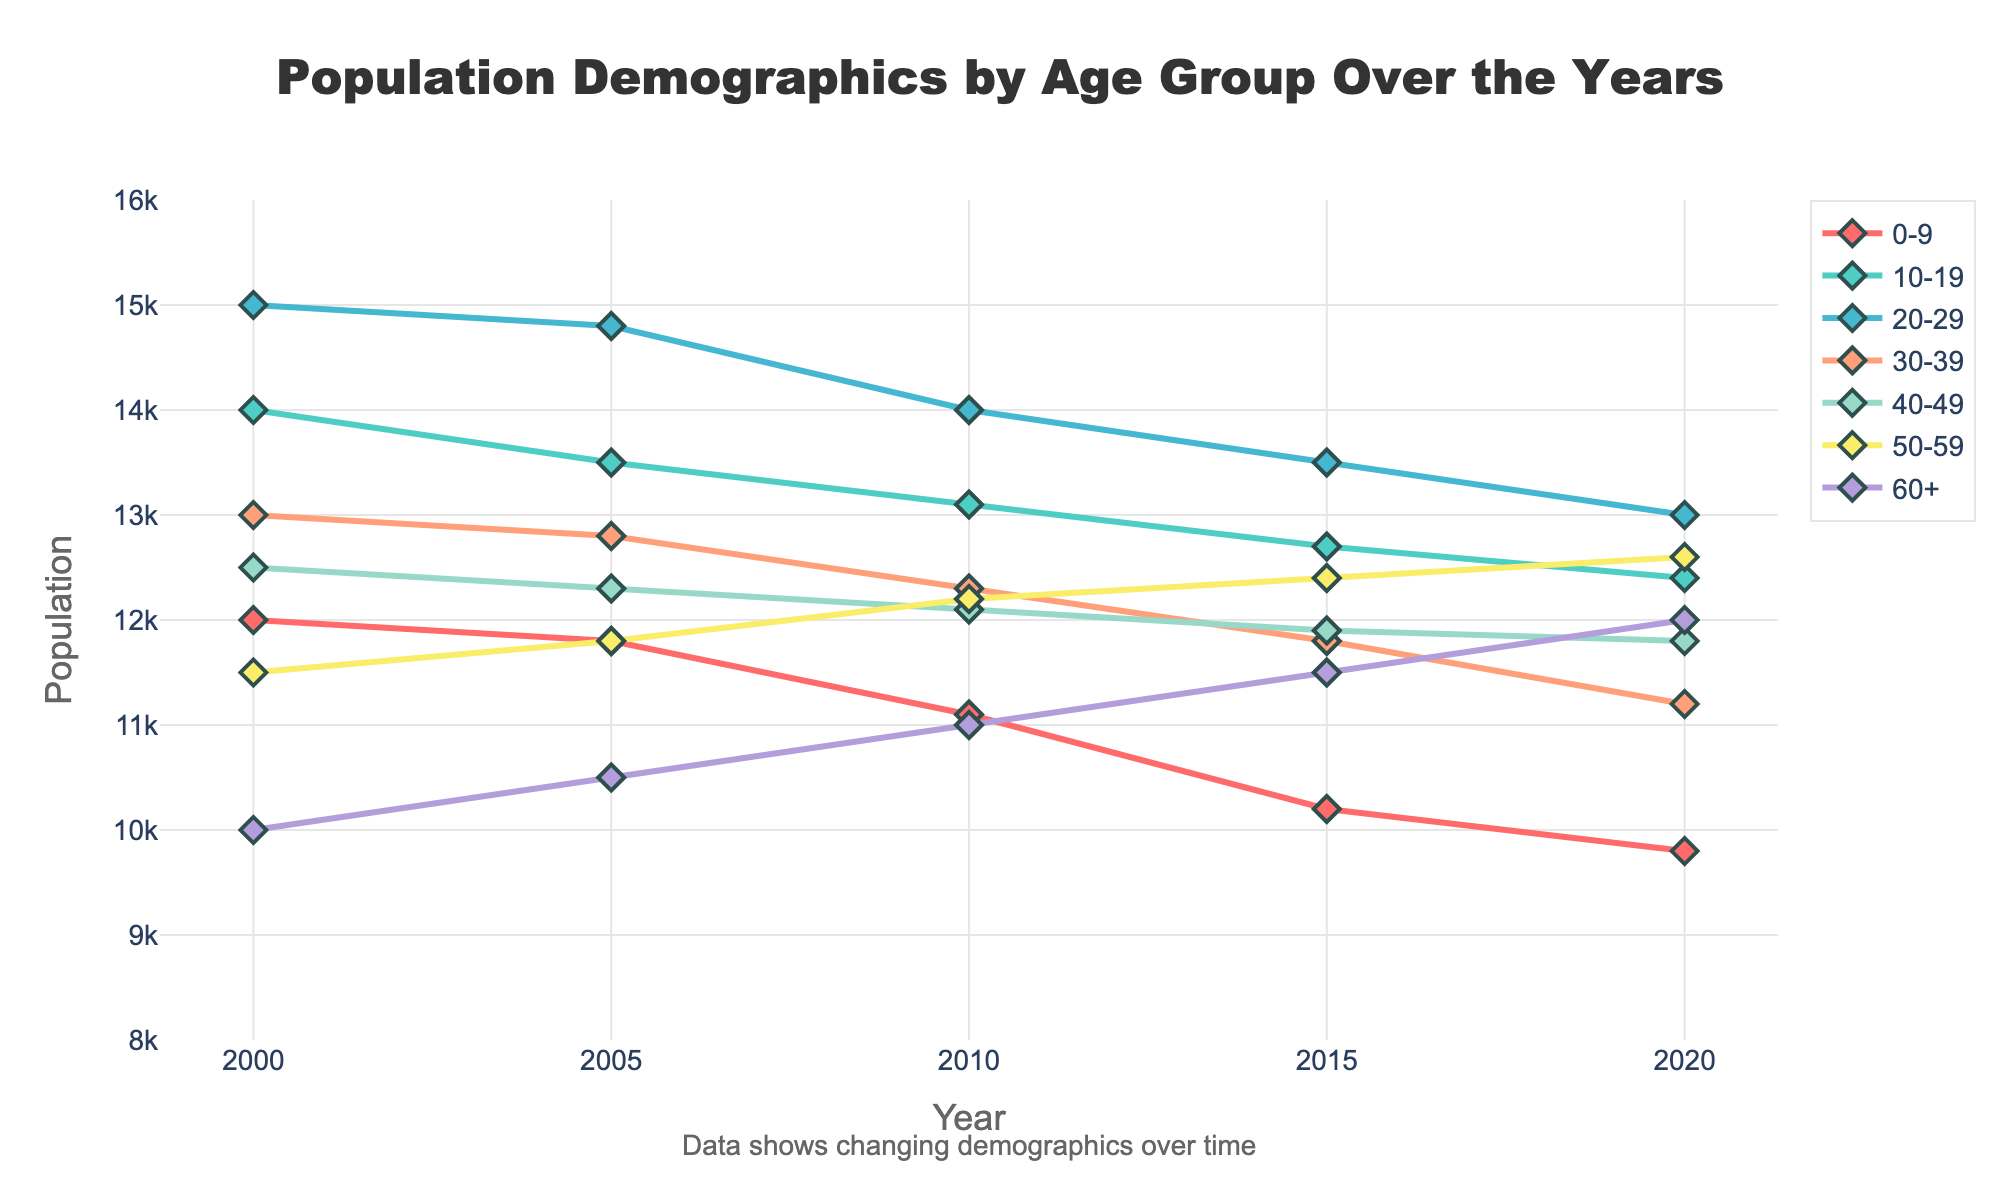what is the title of the figure? The title of a figure is usually placed at the top and gives an overview of what the figure is representing. In this case, it's mentioned as "Population Demographics by Age Group Over the Years".
Answer: Population Demographics by Age Group Over the Years what is the range of the y-axis? The y-axis represents the population and its scale can be determined by looking at the lowest and highest values on this axis. The range is mentioned between 8000 and 16000.
Answer: 8000 to 16000 how many age groups are there in this figure? To find the number of age groups, look at the legend or the unique lines/colors representing different groups. The figure has seven unique age groups.
Answer: 7 which age group had the highest population in the year 2000? Look for the year 2000 on the x-axis and compare the dots or lines at this point. The group with the highest value on the y-axis represents the highest population. Age group 20-29 has the highest population in 2000.
Answer: 20-29 which age group has a consistently increasing population from 2000 to 2020? To find the age group with a consistently increasing population, examine the lines for each age group from 2000 to 2020 and see if any line is consistently rising. The age group 60+ shows a consistent increase.
Answer: 60+ how much did the population of age group 0-9 decrease from 2000 to 2020? Find the population of age group 0-9 in 2000 (12000) and in 2020 (9800). Subtract the latter from the former to get the decrease: 12000 - 9800 = 2200.
Answer: 2200 which year had the smallest population for age group 50-59? Compare the y-values for the age group 50-59 across the years. The year 2000 had the smallest population for this age group at 11500.
Answer: 2000 which two age groups had their population cross each other between 2000 and 2020? Look for lines that intersect between 2000 and 2020. The lines for age groups 50-59 and 60+ cross each other between 2000 and 2020.
Answer: 50-59 and 60+ what is the average population of the age group 20-29 over the years shown? Sum the population values for age group 20-29 for all years: 15000 + 14800 + 14000 + 13500 + 13000 = 70300. Divide by the number of years (5): 70300 / 5 = 14060.
Answer: 14060 which age group had the largest decline in population from 2000 to 2020? Subtract the 2020 population from the 2000 population for each age group and compare the differences. Age group 0-9 had the largest decline: 12000 - 9800 = 2200.
Answer: 0-9 